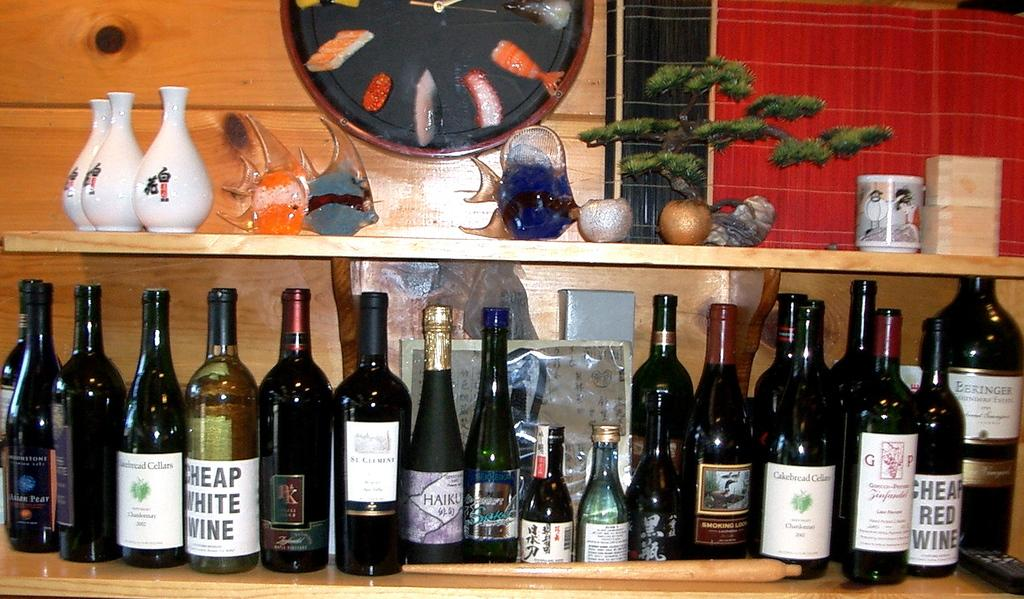<image>
Create a compact narrative representing the image presented. Several bottles of alcohol, including Cheap White Wine, on the shelf below some ceramic mugs and fish figures. 